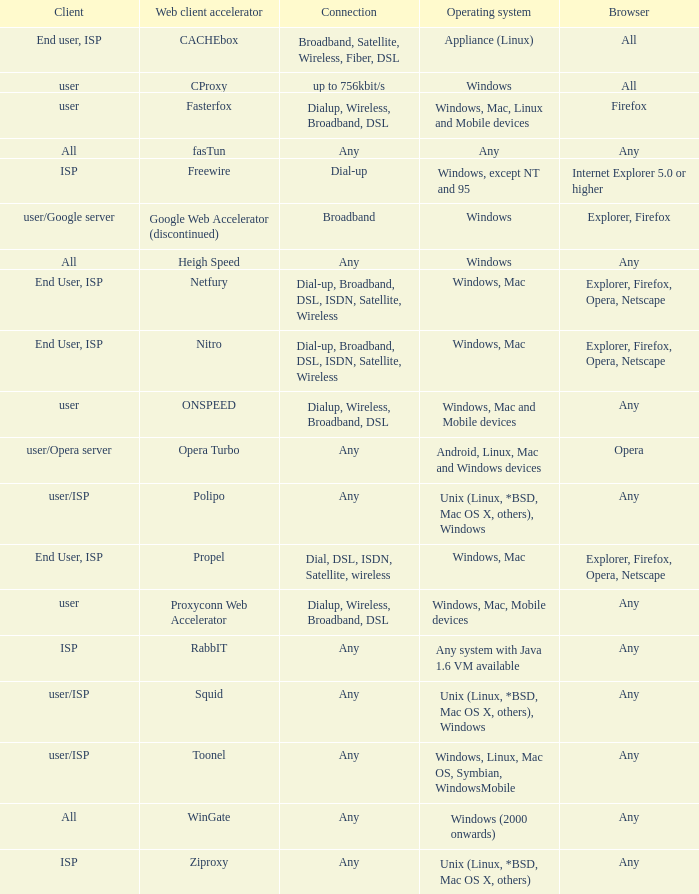What is the connection for the proxyconn web accelerator web client accelerator? Dialup, Wireless, Broadband, DSL. 